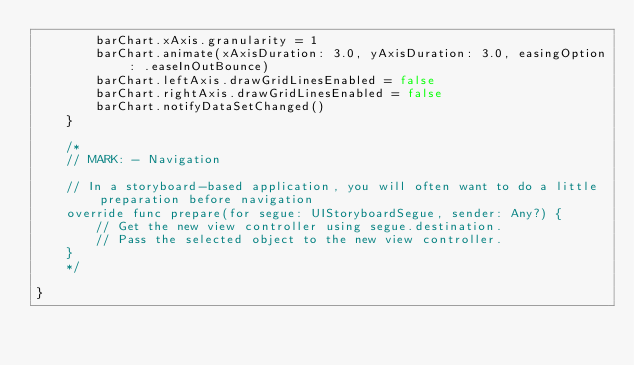<code> <loc_0><loc_0><loc_500><loc_500><_Swift_>        barChart.xAxis.granularity = 1
        barChart.animate(xAxisDuration: 3.0, yAxisDuration: 3.0, easingOption: .easeInOutBounce)
        barChart.leftAxis.drawGridLinesEnabled = false
        barChart.rightAxis.drawGridLinesEnabled = false
        barChart.notifyDataSetChanged()
    }
    
    /*
    // MARK: - Navigation

    // In a storyboard-based application, you will often want to do a little preparation before navigation
    override func prepare(for segue: UIStoryboardSegue, sender: Any?) {
        // Get the new view controller using segue.destination.
        // Pass the selected object to the new view controller.
    }
    */

}
</code> 